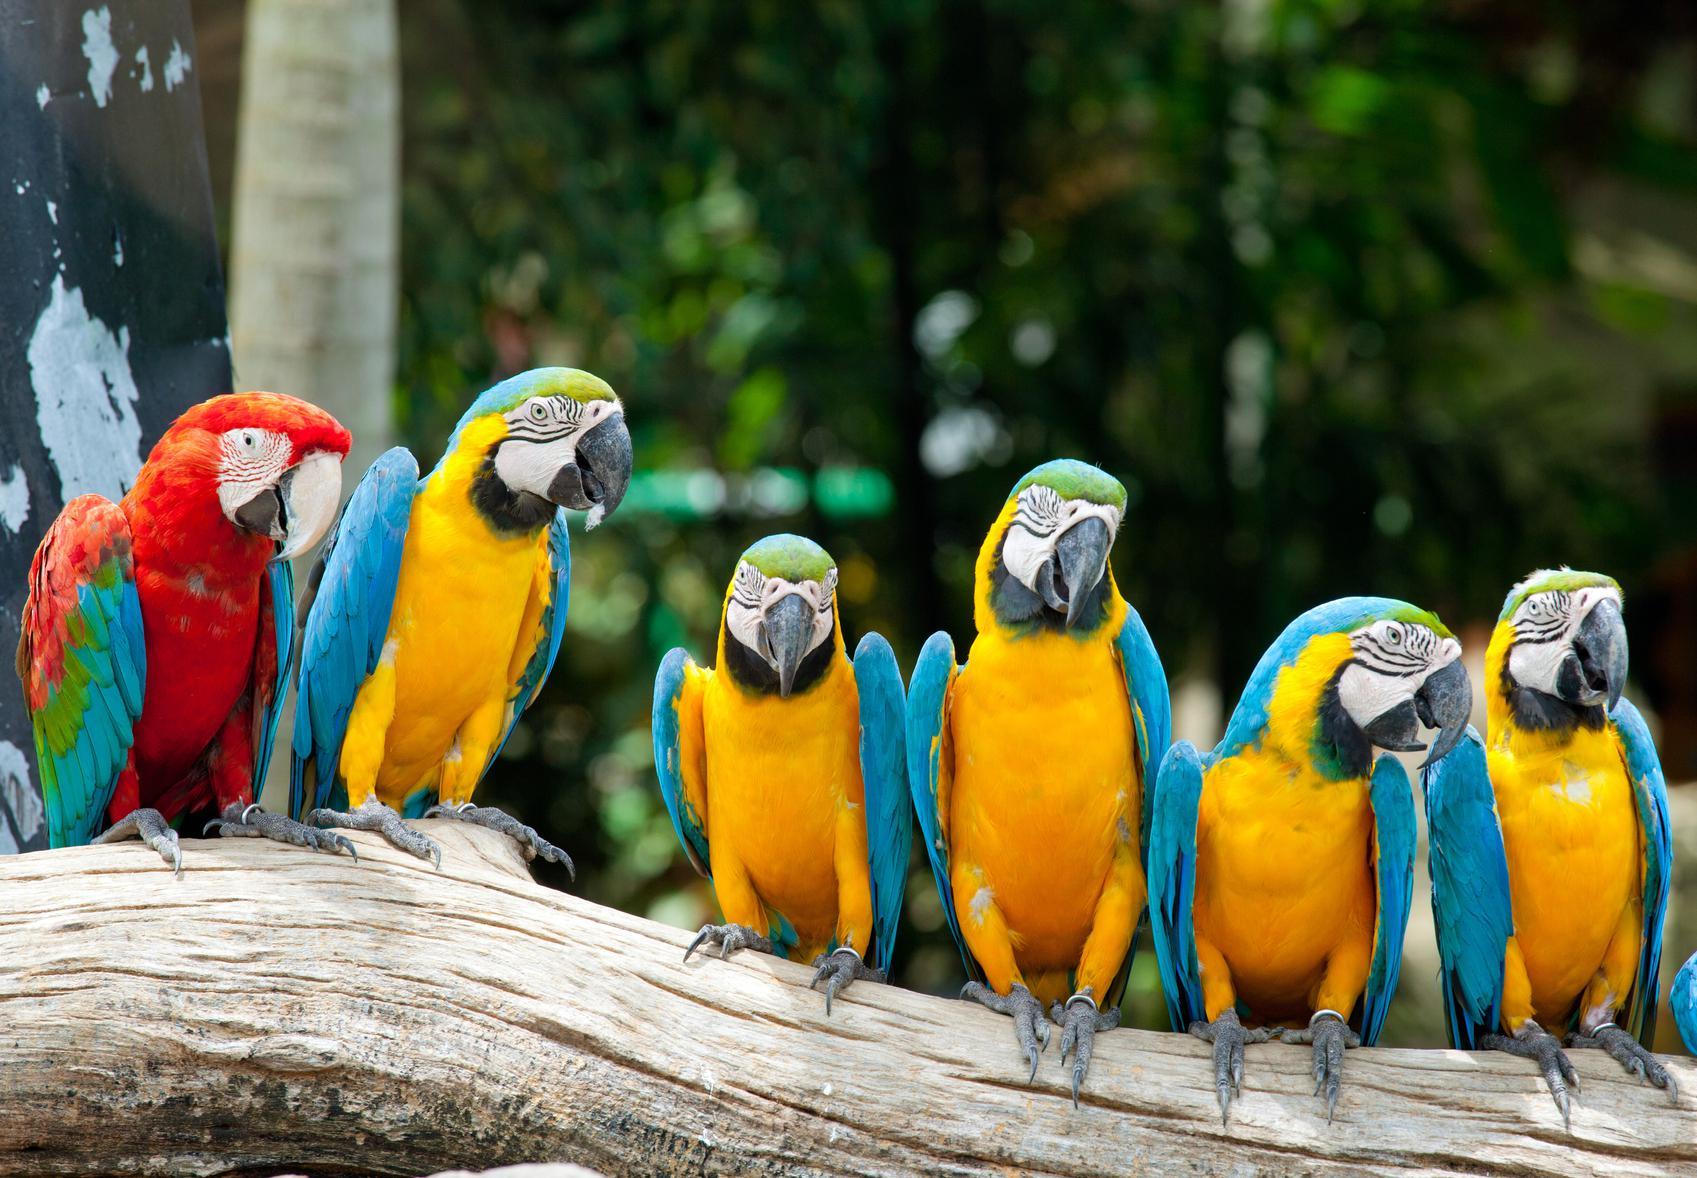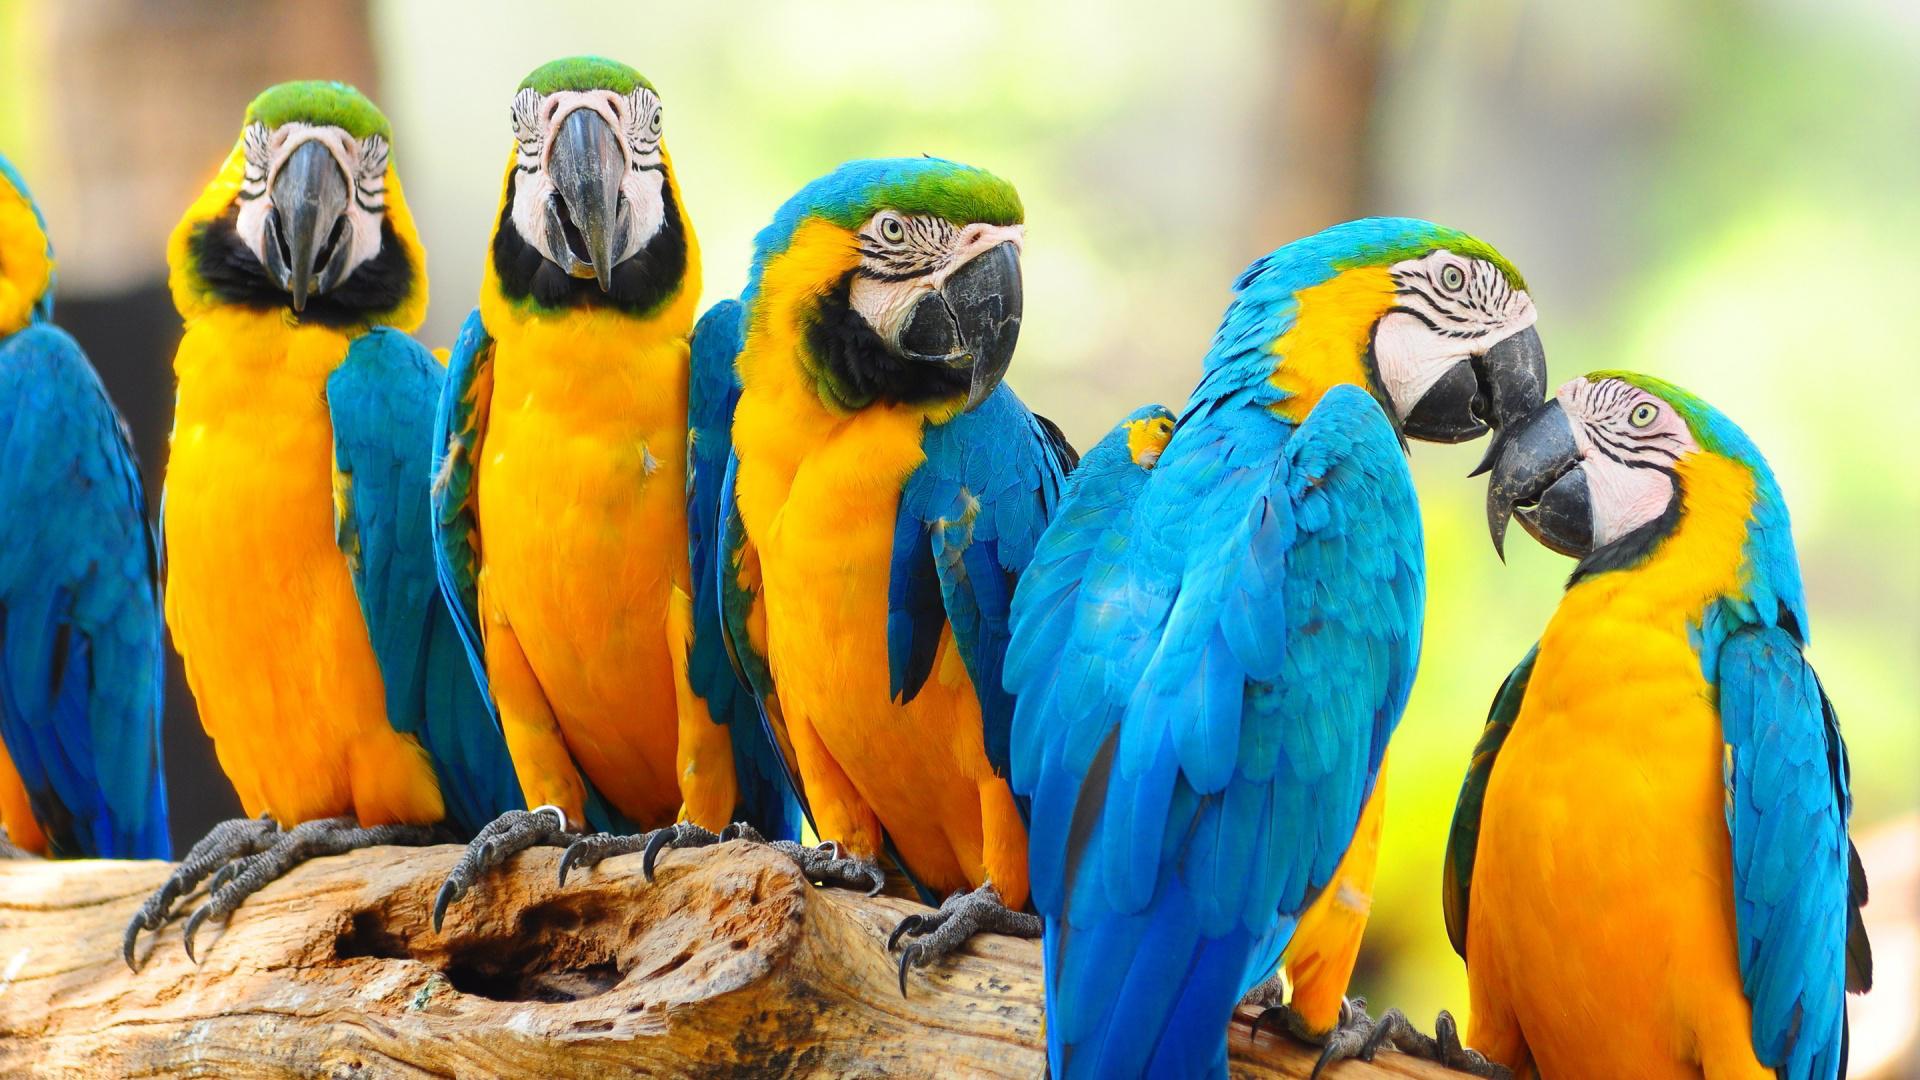The first image is the image on the left, the second image is the image on the right. For the images displayed, is the sentence "The right image shows a row of at least five blue and yellow-orange parrots." factually correct? Answer yes or no. Yes. The first image is the image on the left, the second image is the image on the right. Examine the images to the left and right. Is the description "One image contains exactly six birds." accurate? Answer yes or no. Yes. 